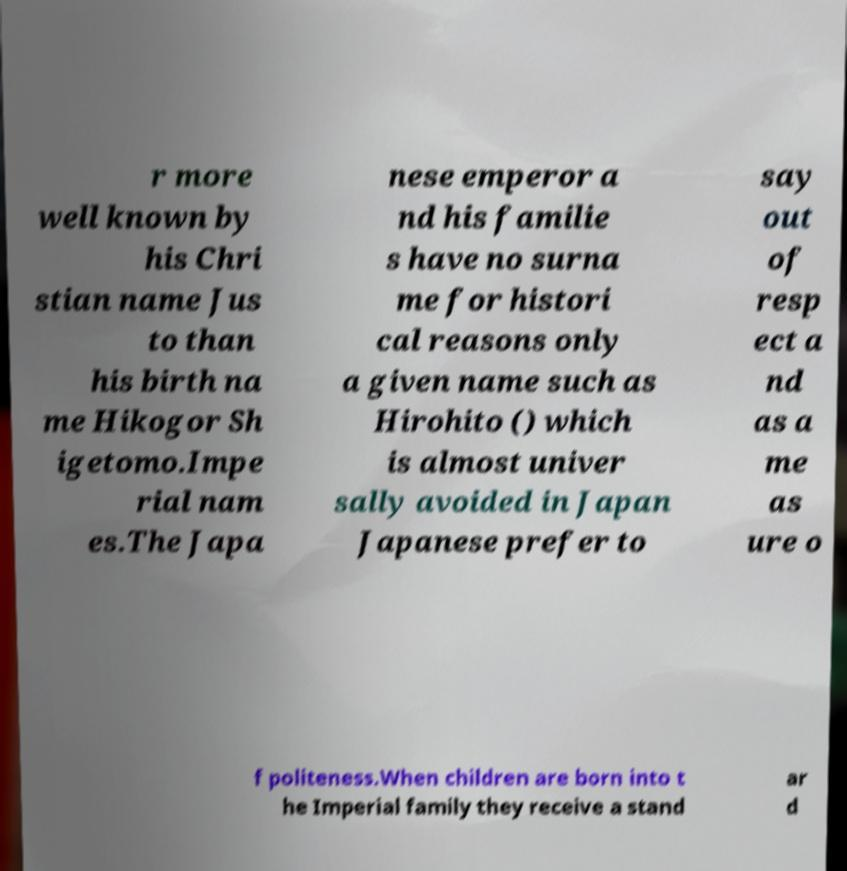What messages or text are displayed in this image? I need them in a readable, typed format. r more well known by his Chri stian name Jus to than his birth na me Hikogor Sh igetomo.Impe rial nam es.The Japa nese emperor a nd his familie s have no surna me for histori cal reasons only a given name such as Hirohito () which is almost univer sally avoided in Japan Japanese prefer to say out of resp ect a nd as a me as ure o f politeness.When children are born into t he Imperial family they receive a stand ar d 